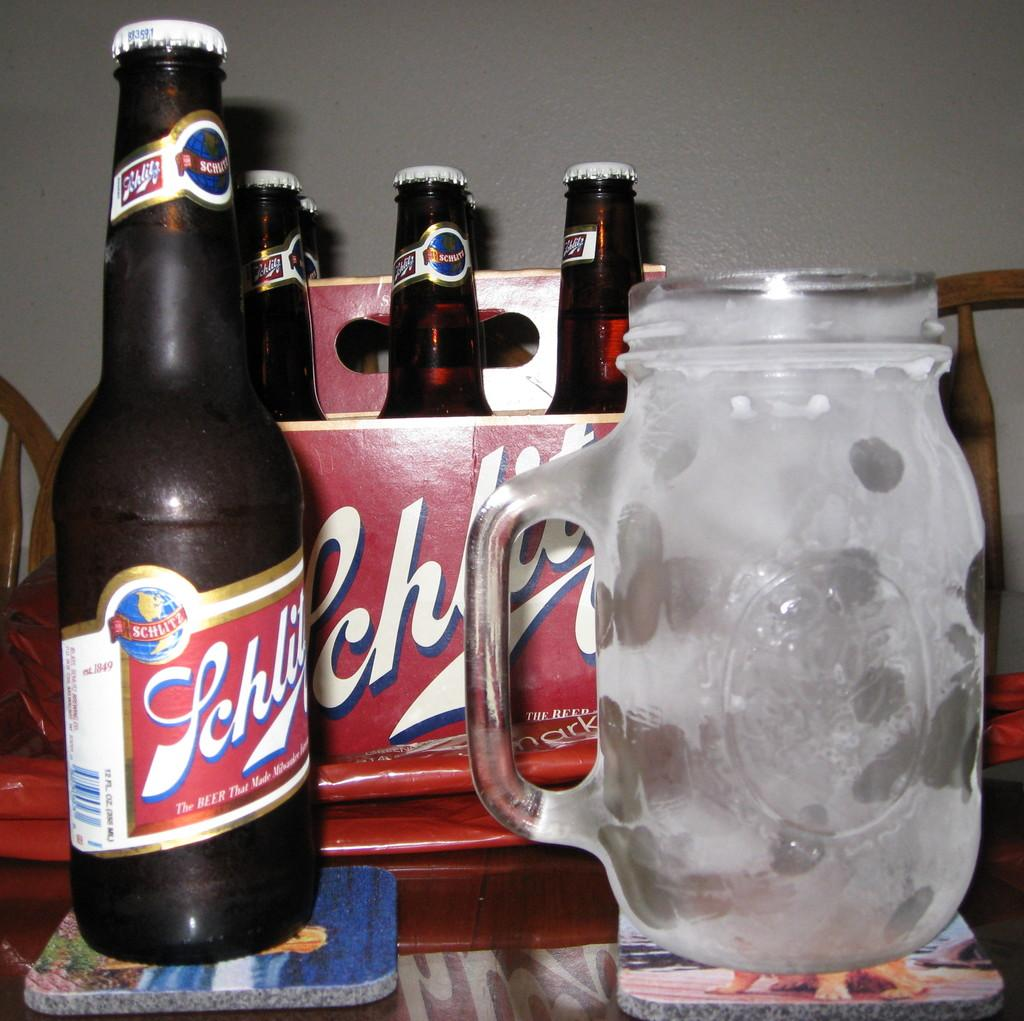<image>
Offer a succinct explanation of the picture presented. a case of Schlitz liquor with one bottle out next to a big drinking glass. 